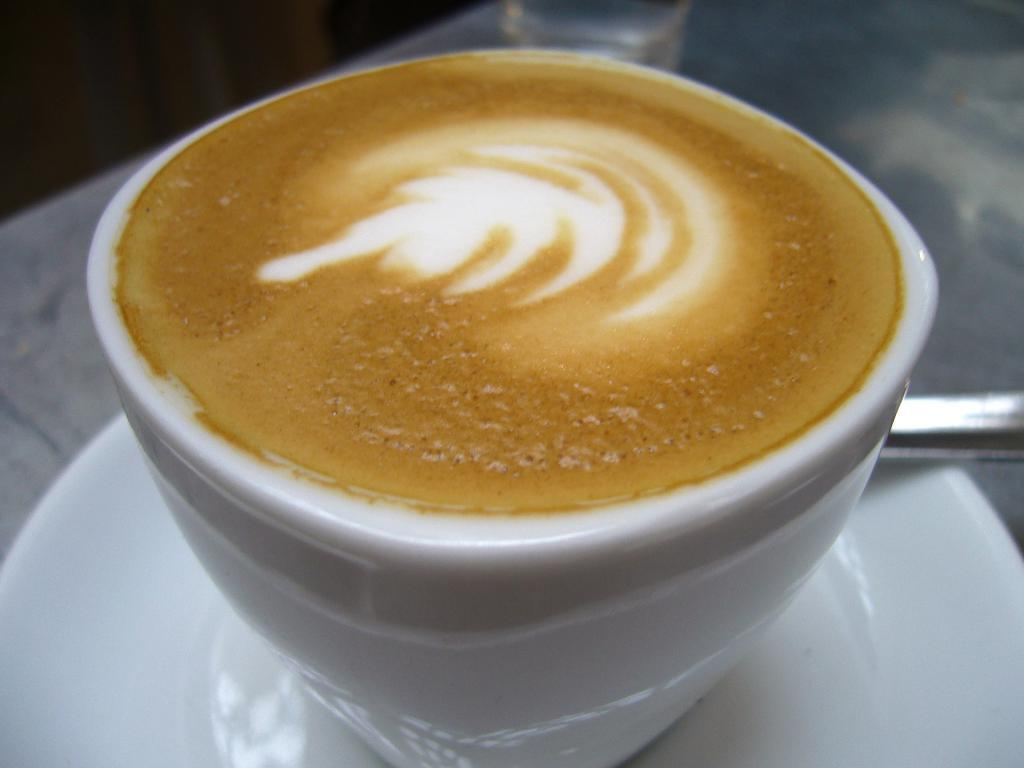What piece of furniture is present in the image? There is a table in the image. What is placed on the table? There is a glass, a saucer, a spoon, and a cup with coffee on the table. What type of beverage is in the cup? The cup contains coffee. What type of baseball is visible on the table? There is no baseball present in the image. What country is depicted on the saucer? The saucer does not depict any country; it is a plain saucer. 